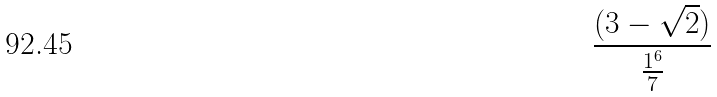Convert formula to latex. <formula><loc_0><loc_0><loc_500><loc_500>\frac { ( 3 - \sqrt { 2 } ) } { \frac { 1 ^ { 6 } } { 7 } }</formula> 